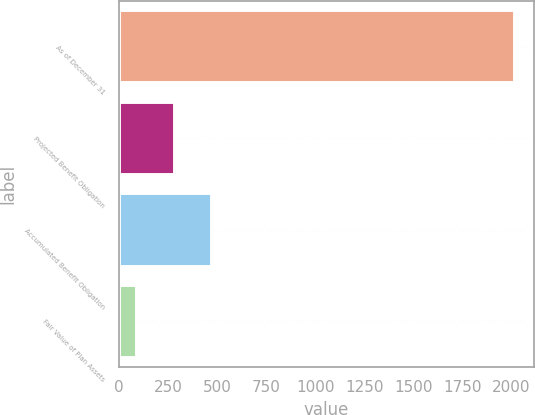Convert chart to OTSL. <chart><loc_0><loc_0><loc_500><loc_500><bar_chart><fcel>As of December 31<fcel>Projected Benefit Obligation<fcel>Accumulated Benefit Obligation<fcel>Fair Value of Plan Assets<nl><fcel>2017<fcel>283.6<fcel>476.2<fcel>91<nl></chart> 